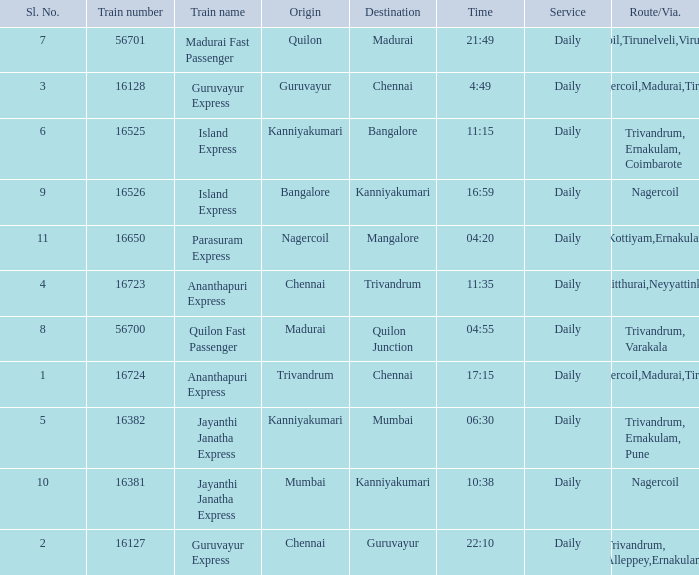What is the train number when the time is 10:38? 16381.0. 